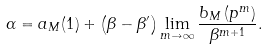<formula> <loc_0><loc_0><loc_500><loc_500>\alpha = a _ { M } ( 1 ) + \left ( \beta - \beta ^ { \prime } \right ) \lim _ { m \to \infty } \frac { b _ { M } \left ( p ^ { m } \right ) } { \beta ^ { m + 1 } } .</formula> 